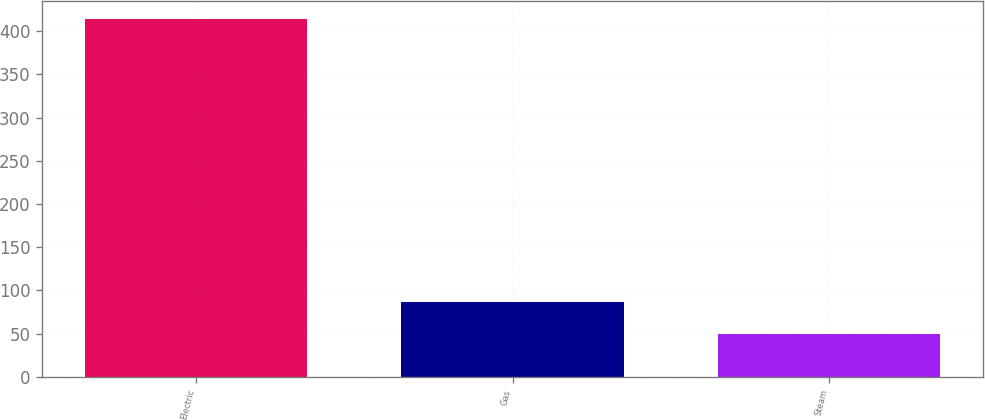Convert chart to OTSL. <chart><loc_0><loc_0><loc_500><loc_500><bar_chart><fcel>Electric<fcel>Gas<fcel>Steam<nl><fcel>414<fcel>86.4<fcel>50<nl></chart> 